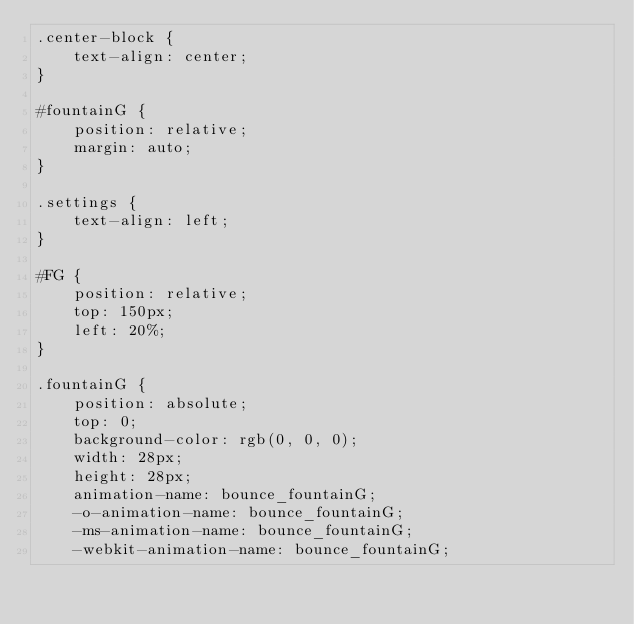Convert code to text. <code><loc_0><loc_0><loc_500><loc_500><_CSS_>.center-block {
    text-align: center;
}

#fountainG {
    position: relative;
    margin: auto;
}

.settings {
    text-align: left;
}

#FG {
    position: relative;
    top: 150px;
    left: 20%;
}

.fountainG {
    position: absolute;
    top: 0;
    background-color: rgb(0, 0, 0);
    width: 28px;
    height: 28px;
    animation-name: bounce_fountainG;
    -o-animation-name: bounce_fountainG;
    -ms-animation-name: bounce_fountainG;
    -webkit-animation-name: bounce_fountainG;</code> 